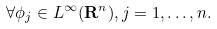<formula> <loc_0><loc_0><loc_500><loc_500>\forall \phi _ { j } \in L ^ { \infty } ( { \mathbf R } ^ { n } ) , j = 1 , \dots , n .</formula> 